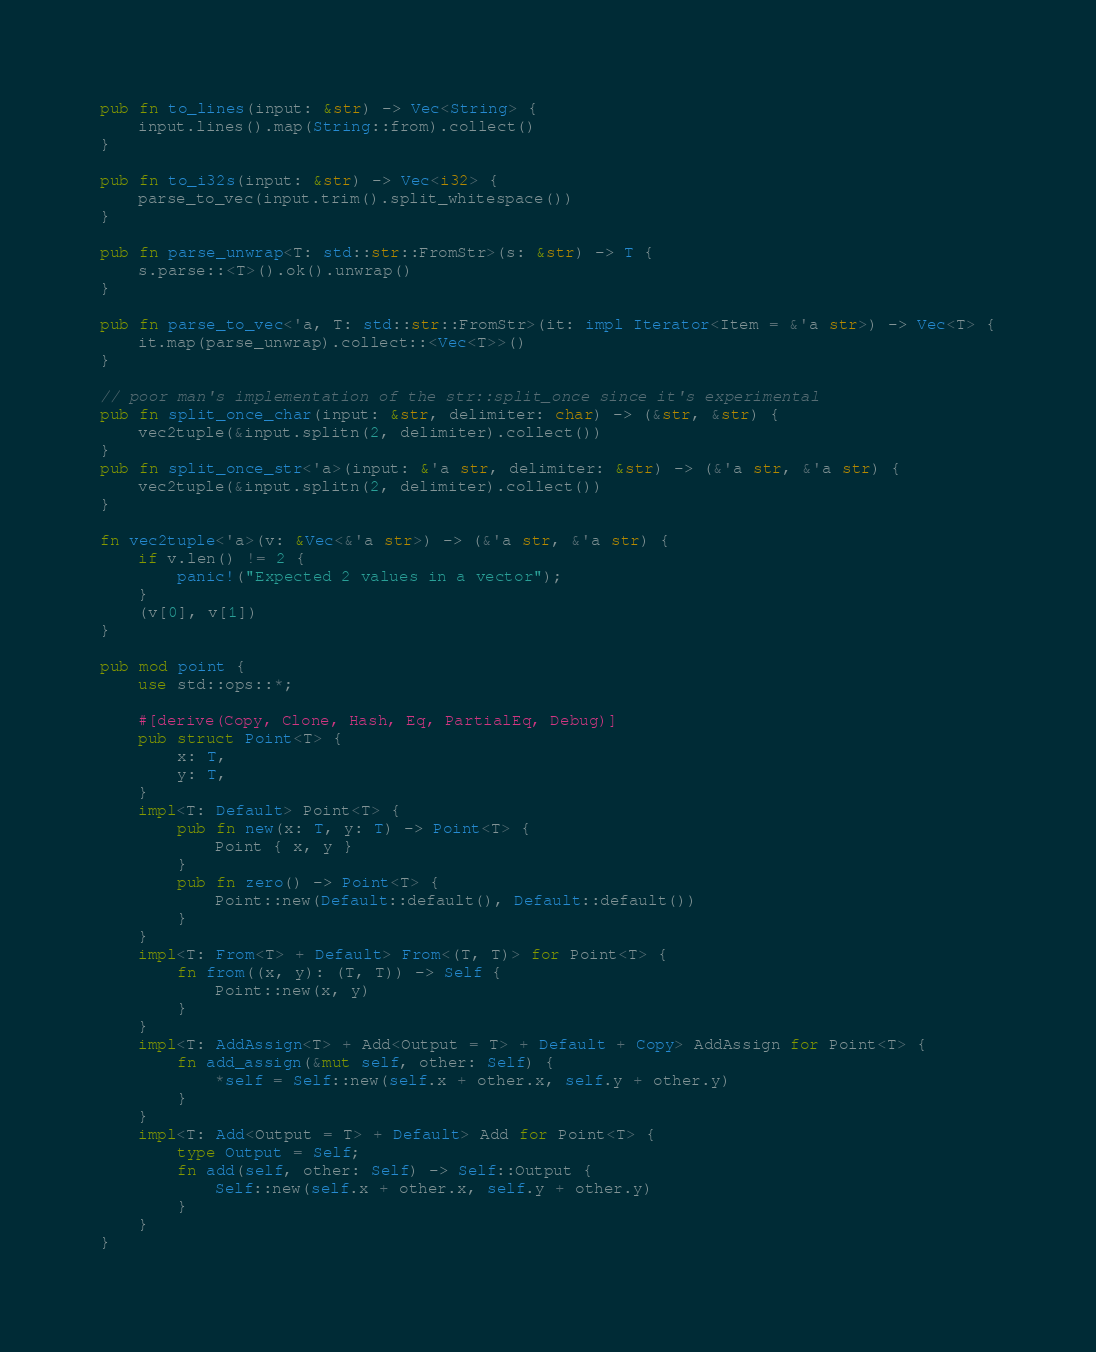Convert code to text. <code><loc_0><loc_0><loc_500><loc_500><_Rust_>pub fn to_lines(input: &str) -> Vec<String> {
    input.lines().map(String::from).collect()
}

pub fn to_i32s(input: &str) -> Vec<i32> {
    parse_to_vec(input.trim().split_whitespace())
}

pub fn parse_unwrap<T: std::str::FromStr>(s: &str) -> T {
    s.parse::<T>().ok().unwrap()
}

pub fn parse_to_vec<'a, T: std::str::FromStr>(it: impl Iterator<Item = &'a str>) -> Vec<T> {
    it.map(parse_unwrap).collect::<Vec<T>>()
}

// poor man's implementation of the str::split_once since it's experimental
pub fn split_once_char(input: &str, delimiter: char) -> (&str, &str) {
    vec2tuple(&input.splitn(2, delimiter).collect())
}
pub fn split_once_str<'a>(input: &'a str, delimiter: &str) -> (&'a str, &'a str) {
    vec2tuple(&input.splitn(2, delimiter).collect())
}

fn vec2tuple<'a>(v: &Vec<&'a str>) -> (&'a str, &'a str) {
    if v.len() != 2 {
        panic!("Expected 2 values in a vector");
    }
    (v[0], v[1])
}

pub mod point {
    use std::ops::*;

    #[derive(Copy, Clone, Hash, Eq, PartialEq, Debug)]
    pub struct Point<T> {
        x: T,
        y: T,
    }
    impl<T: Default> Point<T> {
        pub fn new(x: T, y: T) -> Point<T> {
            Point { x, y }
        }
        pub fn zero() -> Point<T> {
            Point::new(Default::default(), Default::default())
        }
    }
    impl<T: From<T> + Default> From<(T, T)> for Point<T> {
        fn from((x, y): (T, T)) -> Self {
            Point::new(x, y)
        }
    }
    impl<T: AddAssign<T> + Add<Output = T> + Default + Copy> AddAssign for Point<T> {
        fn add_assign(&mut self, other: Self) {
            *self = Self::new(self.x + other.x, self.y + other.y)
        }
    }
    impl<T: Add<Output = T> + Default> Add for Point<T> {
        type Output = Self;
        fn add(self, other: Self) -> Self::Output {
            Self::new(self.x + other.x, self.y + other.y)
        }
    }
}
</code> 